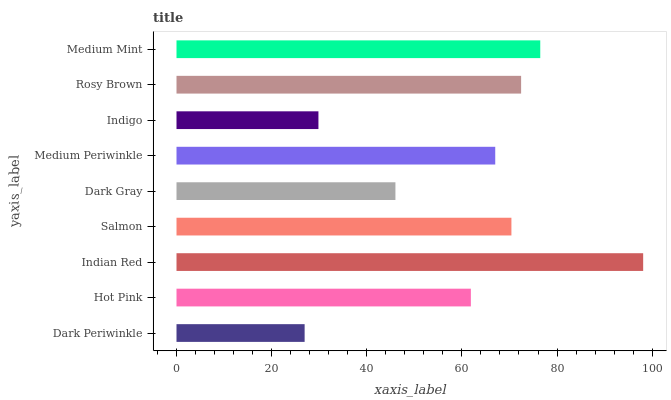Is Dark Periwinkle the minimum?
Answer yes or no. Yes. Is Indian Red the maximum?
Answer yes or no. Yes. Is Hot Pink the minimum?
Answer yes or no. No. Is Hot Pink the maximum?
Answer yes or no. No. Is Hot Pink greater than Dark Periwinkle?
Answer yes or no. Yes. Is Dark Periwinkle less than Hot Pink?
Answer yes or no. Yes. Is Dark Periwinkle greater than Hot Pink?
Answer yes or no. No. Is Hot Pink less than Dark Periwinkle?
Answer yes or no. No. Is Medium Periwinkle the high median?
Answer yes or no. Yes. Is Medium Periwinkle the low median?
Answer yes or no. Yes. Is Medium Mint the high median?
Answer yes or no. No. Is Rosy Brown the low median?
Answer yes or no. No. 